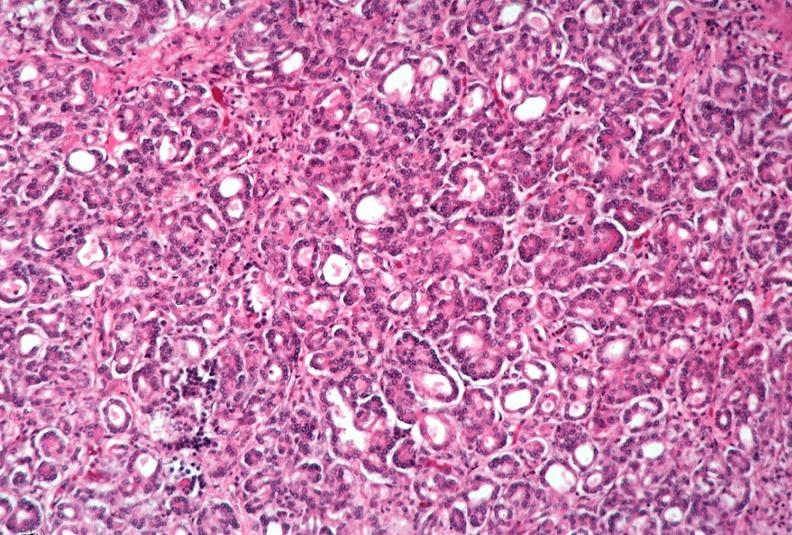why does this image show pancreas, uremic pancreatitis?
Answer the question using a single word or phrase. Due to polycystic kidney 